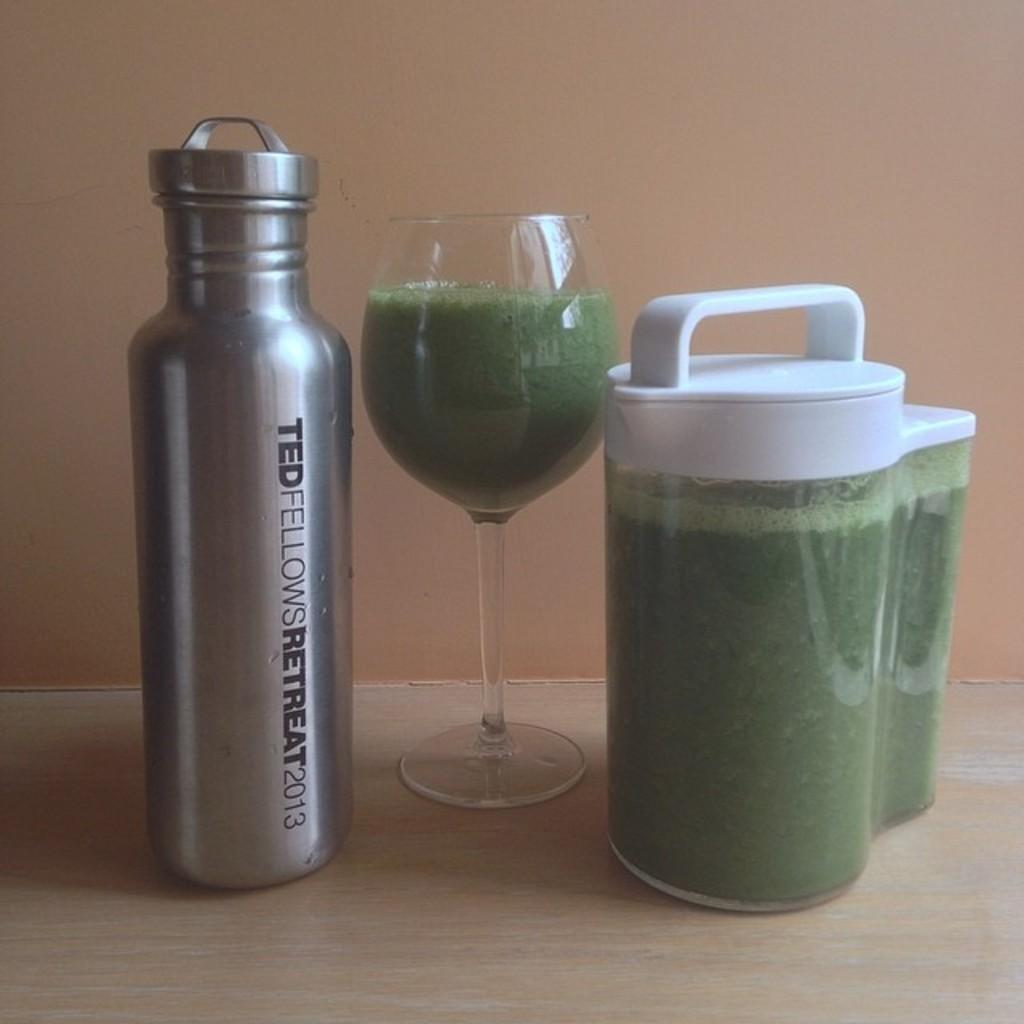<image>
Write a terse but informative summary of the picture. A metal bottle from the Ted Fellows Retreat in 2013 sits next to a green drink. 